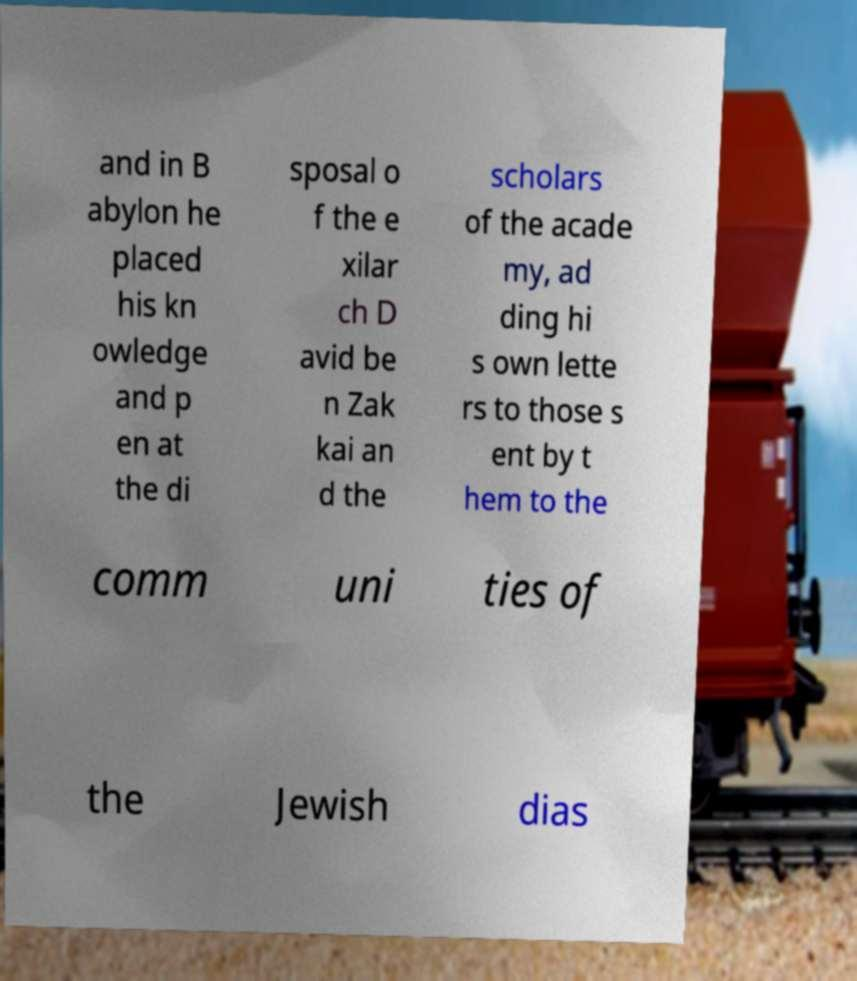For documentation purposes, I need the text within this image transcribed. Could you provide that? and in B abylon he placed his kn owledge and p en at the di sposal o f the e xilar ch D avid be n Zak kai an d the scholars of the acade my, ad ding hi s own lette rs to those s ent by t hem to the comm uni ties of the Jewish dias 